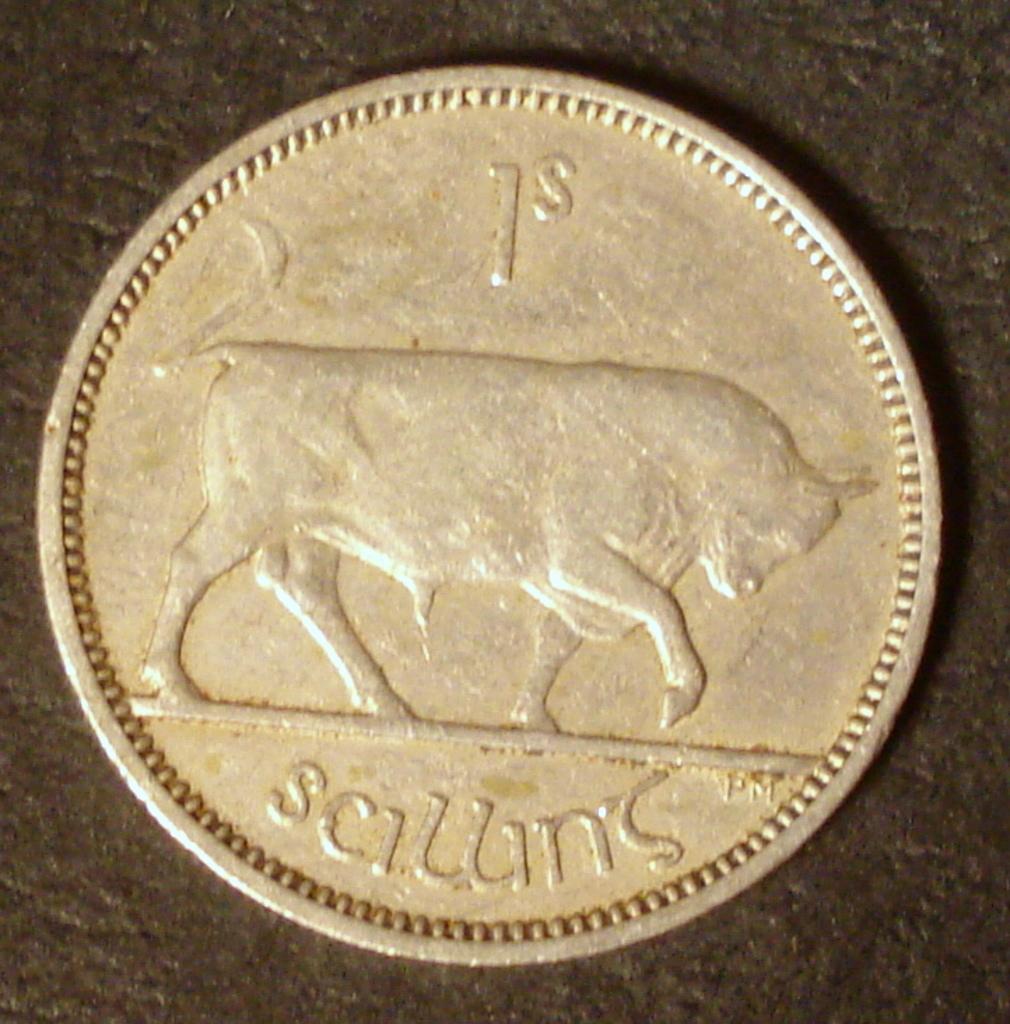How much is this coin worth?
Offer a very short reply. 1s. What is the value?
Your answer should be very brief. 1. 